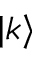Convert formula to latex. <formula><loc_0><loc_0><loc_500><loc_500>| k \rangle</formula> 